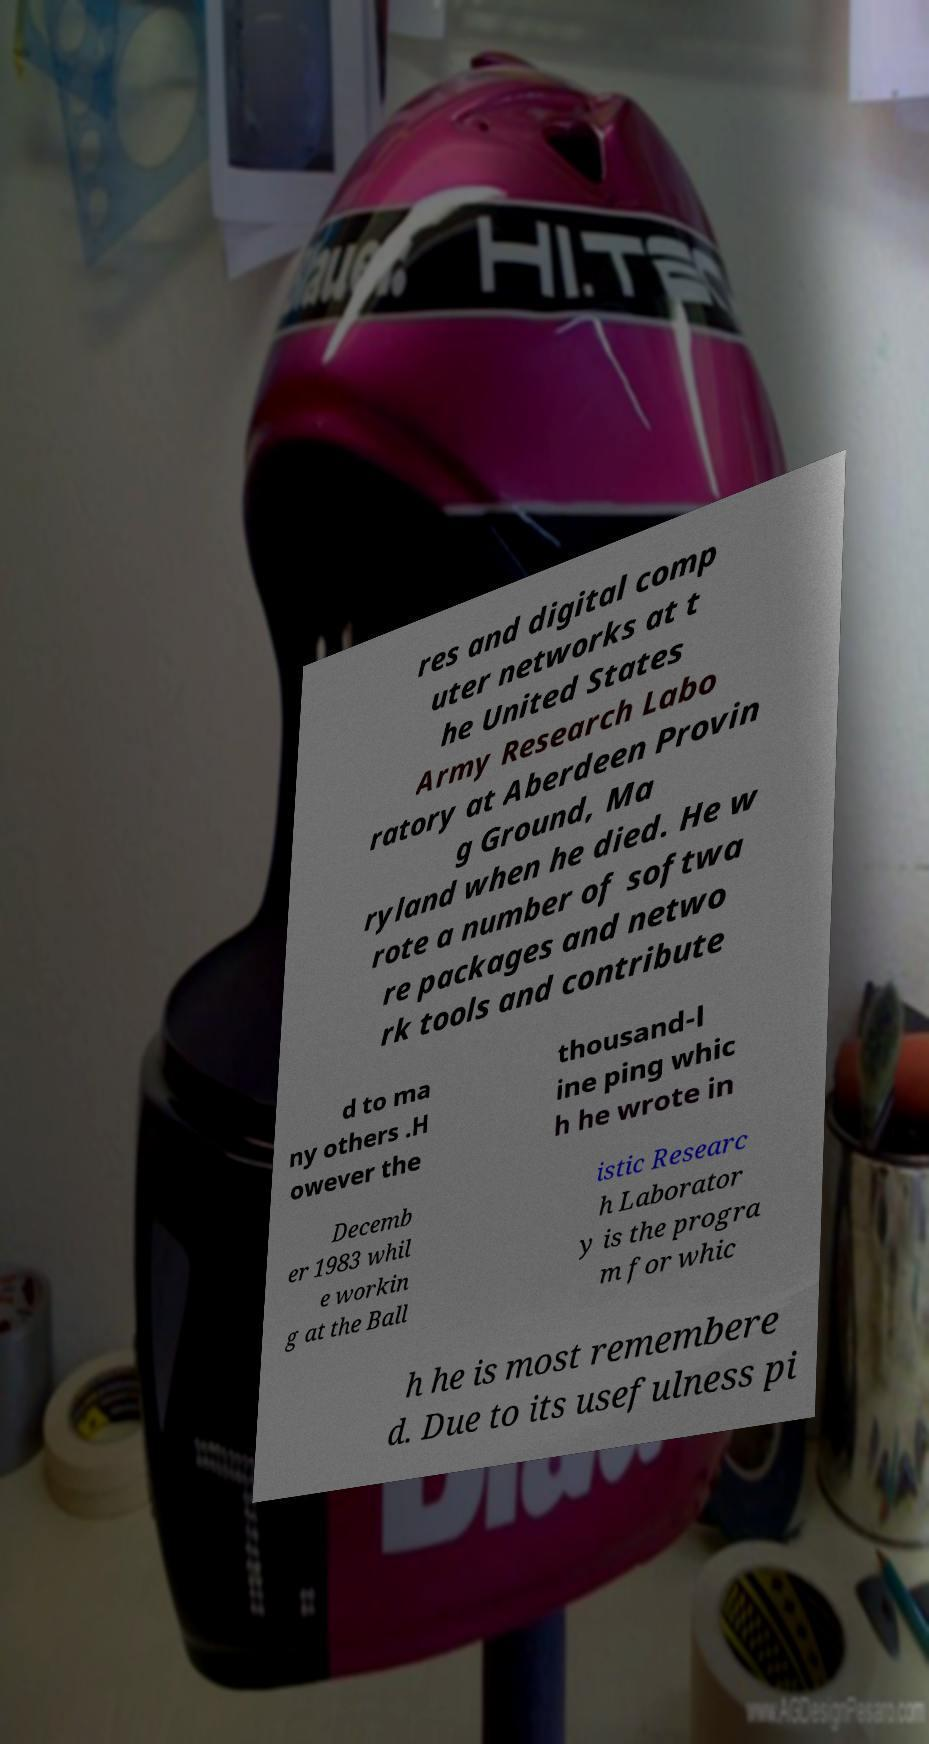Can you read and provide the text displayed in the image?This photo seems to have some interesting text. Can you extract and type it out for me? res and digital comp uter networks at t he United States Army Research Labo ratory at Aberdeen Provin g Ground, Ma ryland when he died. He w rote a number of softwa re packages and netwo rk tools and contribute d to ma ny others .H owever the thousand-l ine ping whic h he wrote in Decemb er 1983 whil e workin g at the Ball istic Researc h Laborator y is the progra m for whic h he is most remembere d. Due to its usefulness pi 